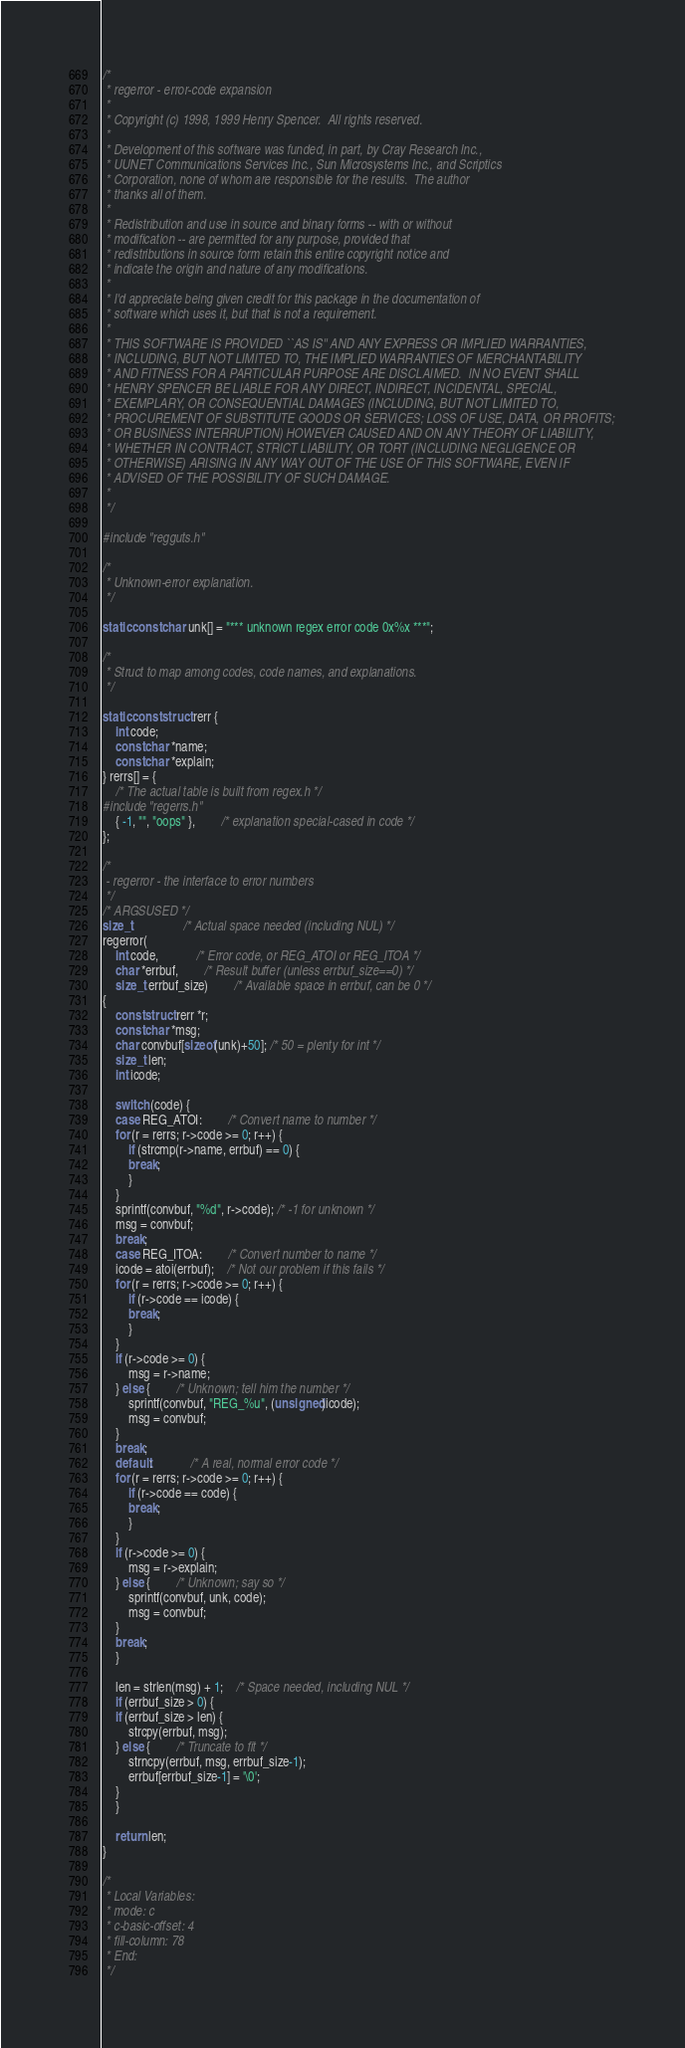<code> <loc_0><loc_0><loc_500><loc_500><_C_>/*
 * regerror - error-code expansion
 *
 * Copyright (c) 1998, 1999 Henry Spencer.  All rights reserved.
 *
 * Development of this software was funded, in part, by Cray Research Inc.,
 * UUNET Communications Services Inc., Sun Microsystems Inc., and Scriptics
 * Corporation, none of whom are responsible for the results.  The author
 * thanks all of them.
 *
 * Redistribution and use in source and binary forms -- with or without
 * modification -- are permitted for any purpose, provided that
 * redistributions in source form retain this entire copyright notice and
 * indicate the origin and nature of any modifications.
 *
 * I'd appreciate being given credit for this package in the documentation of
 * software which uses it, but that is not a requirement.
 *
 * THIS SOFTWARE IS PROVIDED ``AS IS'' AND ANY EXPRESS OR IMPLIED WARRANTIES,
 * INCLUDING, BUT NOT LIMITED TO, THE IMPLIED WARRANTIES OF MERCHANTABILITY
 * AND FITNESS FOR A PARTICULAR PURPOSE ARE DISCLAIMED.  IN NO EVENT SHALL
 * HENRY SPENCER BE LIABLE FOR ANY DIRECT, INDIRECT, INCIDENTAL, SPECIAL,
 * EXEMPLARY, OR CONSEQUENTIAL DAMAGES (INCLUDING, BUT NOT LIMITED TO,
 * PROCUREMENT OF SUBSTITUTE GOODS OR SERVICES; LOSS OF USE, DATA, OR PROFITS;
 * OR BUSINESS INTERRUPTION) HOWEVER CAUSED AND ON ANY THEORY OF LIABILITY,
 * WHETHER IN CONTRACT, STRICT LIABILITY, OR TORT (INCLUDING NEGLIGENCE OR
 * OTHERWISE) ARISING IN ANY WAY OUT OF THE USE OF THIS SOFTWARE, EVEN IF
 * ADVISED OF THE POSSIBILITY OF SUCH DAMAGE.
 *
 */

#include "regguts.h"

/*
 * Unknown-error explanation.
 */

static const char unk[] = "*** unknown regex error code 0x%x ***";

/*
 * Struct to map among codes, code names, and explanations.
 */

static const struct rerr {
    int code;
    const char *name;
    const char *explain;
} rerrs[] = {
    /* The actual table is built from regex.h */
#include "regerrs.h"
    { -1, "", "oops" },		/* explanation special-cased in code */
};

/*
 - regerror - the interface to error numbers
 */
/* ARGSUSED */
size_t				/* Actual space needed (including NUL) */
regerror(
    int code,			/* Error code, or REG_ATOI or REG_ITOA */
    char *errbuf,		/* Result buffer (unless errbuf_size==0) */
    size_t errbuf_size)		/* Available space in errbuf, can be 0 */
{
    const struct rerr *r;
    const char *msg;
    char convbuf[sizeof(unk)+50]; /* 50 = plenty for int */
    size_t len;
    int icode;

    switch (code) {
    case REG_ATOI:		/* Convert name to number */
	for (r = rerrs; r->code >= 0; r++) {
	    if (strcmp(r->name, errbuf) == 0) {
		break;
	    }
	}
	sprintf(convbuf, "%d", r->code); /* -1 for unknown */
	msg = convbuf;
	break;
    case REG_ITOA:		/* Convert number to name */
	icode = atoi(errbuf);	/* Not our problem if this fails */
	for (r = rerrs; r->code >= 0; r++) {
	    if (r->code == icode) {
		break;
	    }
	}
	if (r->code >= 0) {
	    msg = r->name;
	} else {		/* Unknown; tell him the number */
	    sprintf(convbuf, "REG_%u", (unsigned)icode);
	    msg = convbuf;
	}
	break;
    default:			/* A real, normal error code */
	for (r = rerrs; r->code >= 0; r++) {
	    if (r->code == code) {
		break;
	    }
	}
	if (r->code >= 0) {
	    msg = r->explain;
	} else {		/* Unknown; say so */
	    sprintf(convbuf, unk, code);
	    msg = convbuf;
	}
	break;
    }

    len = strlen(msg) + 1;	/* Space needed, including NUL */
    if (errbuf_size > 0) {
	if (errbuf_size > len) {
	    strcpy(errbuf, msg);
	} else {		/* Truncate to fit */
	    strncpy(errbuf, msg, errbuf_size-1);
	    errbuf[errbuf_size-1] = '\0';
	}
    }

    return len;
}

/*
 * Local Variables:
 * mode: c
 * c-basic-offset: 4
 * fill-column: 78
 * End:
 */
</code> 